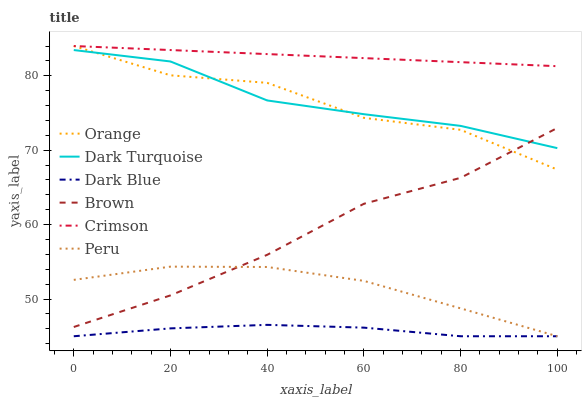Does Dark Blue have the minimum area under the curve?
Answer yes or no. Yes. Does Crimson have the maximum area under the curve?
Answer yes or no. Yes. Does Dark Turquoise have the minimum area under the curve?
Answer yes or no. No. Does Dark Turquoise have the maximum area under the curve?
Answer yes or no. No. Is Crimson the smoothest?
Answer yes or no. Yes. Is Orange the roughest?
Answer yes or no. Yes. Is Dark Blue the smoothest?
Answer yes or no. No. Is Dark Blue the roughest?
Answer yes or no. No. Does Dark Blue have the lowest value?
Answer yes or no. Yes. Does Dark Turquoise have the lowest value?
Answer yes or no. No. Does Orange have the highest value?
Answer yes or no. Yes. Does Dark Turquoise have the highest value?
Answer yes or no. No. Is Dark Blue less than Brown?
Answer yes or no. Yes. Is Brown greater than Dark Blue?
Answer yes or no. Yes. Does Peru intersect Brown?
Answer yes or no. Yes. Is Peru less than Brown?
Answer yes or no. No. Is Peru greater than Brown?
Answer yes or no. No. Does Dark Blue intersect Brown?
Answer yes or no. No. 